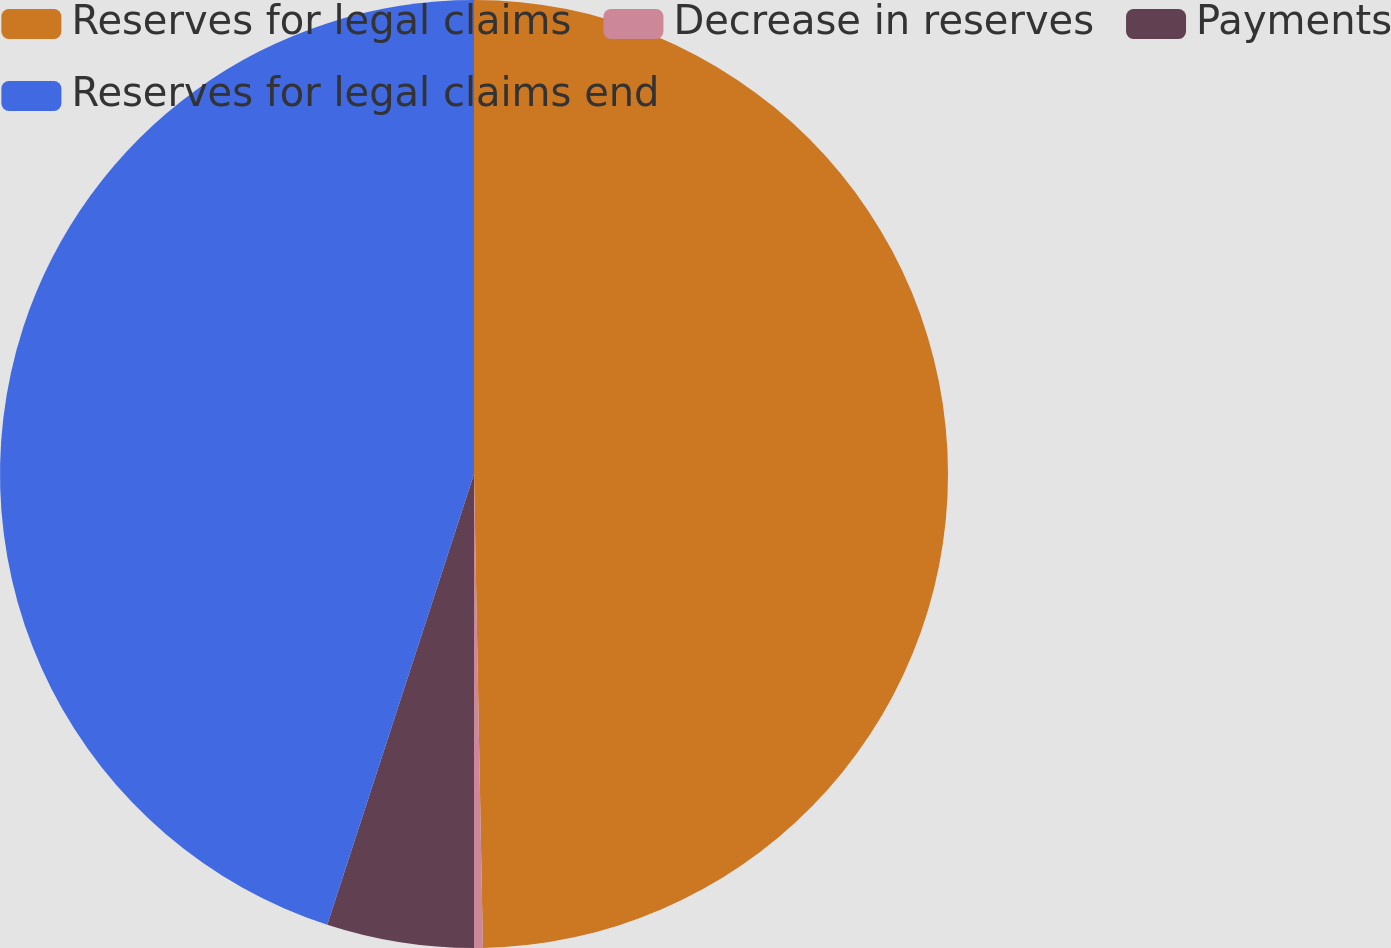Convert chart to OTSL. <chart><loc_0><loc_0><loc_500><loc_500><pie_chart><fcel>Reserves for legal claims<fcel>Decrease in reserves<fcel>Payments<fcel>Reserves for legal claims end<nl><fcel>49.7%<fcel>0.3%<fcel>5.01%<fcel>44.99%<nl></chart> 